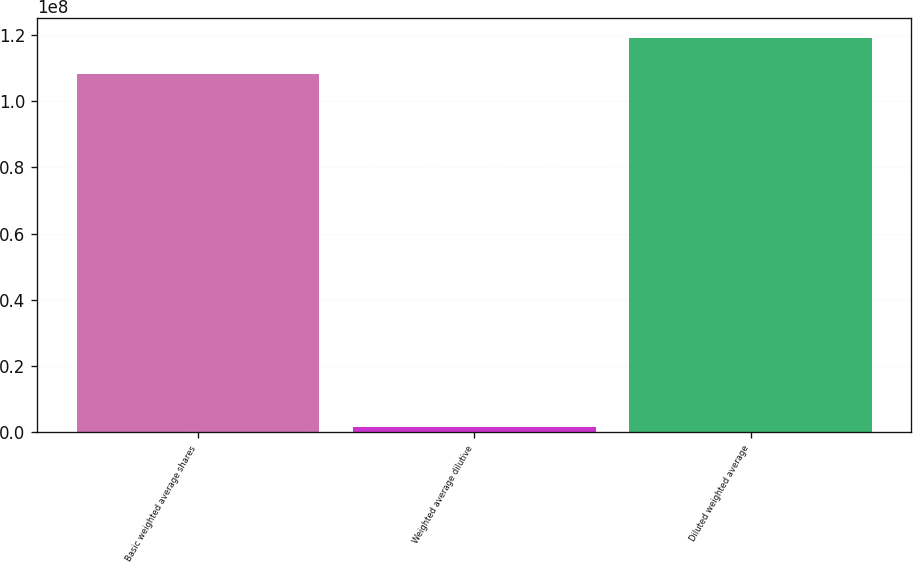Convert chart. <chart><loc_0><loc_0><loc_500><loc_500><bar_chart><fcel>Basic weighted average shares<fcel>Weighted average dilutive<fcel>Diluted weighted average<nl><fcel>1.08278e+08<fcel>1.53728e+06<fcel>1.19106e+08<nl></chart> 